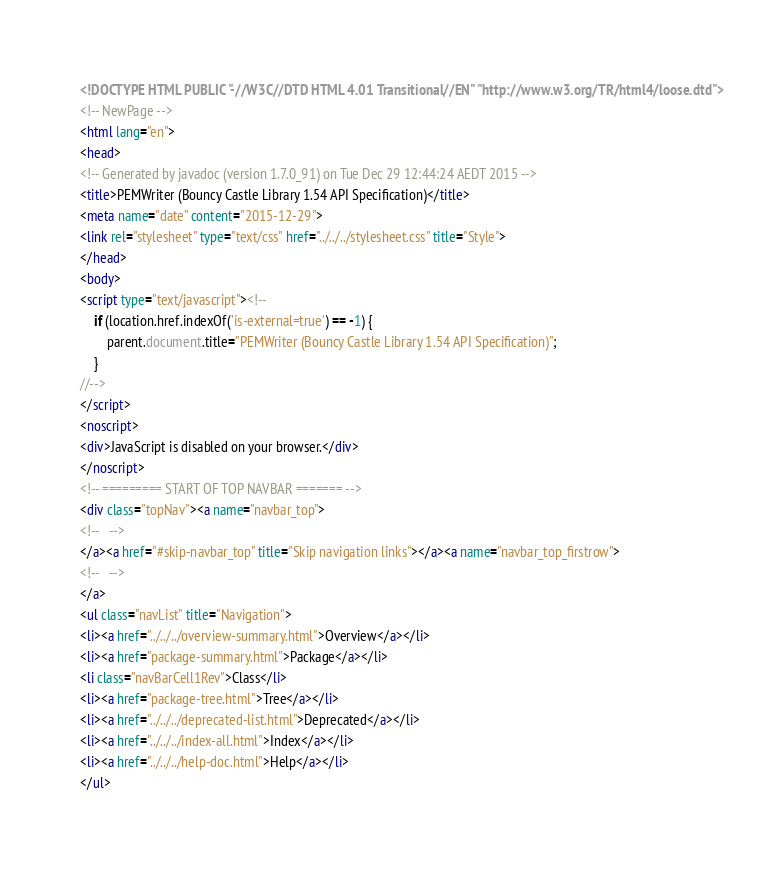<code> <loc_0><loc_0><loc_500><loc_500><_HTML_><!DOCTYPE HTML PUBLIC "-//W3C//DTD HTML 4.01 Transitional//EN" "http://www.w3.org/TR/html4/loose.dtd">
<!-- NewPage -->
<html lang="en">
<head>
<!-- Generated by javadoc (version 1.7.0_91) on Tue Dec 29 12:44:24 AEDT 2015 -->
<title>PEMWriter (Bouncy Castle Library 1.54 API Specification)</title>
<meta name="date" content="2015-12-29">
<link rel="stylesheet" type="text/css" href="../../../stylesheet.css" title="Style">
</head>
<body>
<script type="text/javascript"><!--
    if (location.href.indexOf('is-external=true') == -1) {
        parent.document.title="PEMWriter (Bouncy Castle Library 1.54 API Specification)";
    }
//-->
</script>
<noscript>
<div>JavaScript is disabled on your browser.</div>
</noscript>
<!-- ========= START OF TOP NAVBAR ======= -->
<div class="topNav"><a name="navbar_top">
<!--   -->
</a><a href="#skip-navbar_top" title="Skip navigation links"></a><a name="navbar_top_firstrow">
<!--   -->
</a>
<ul class="navList" title="Navigation">
<li><a href="../../../overview-summary.html">Overview</a></li>
<li><a href="package-summary.html">Package</a></li>
<li class="navBarCell1Rev">Class</li>
<li><a href="package-tree.html">Tree</a></li>
<li><a href="../../../deprecated-list.html">Deprecated</a></li>
<li><a href="../../../index-all.html">Index</a></li>
<li><a href="../../../help-doc.html">Help</a></li>
</ul></code> 